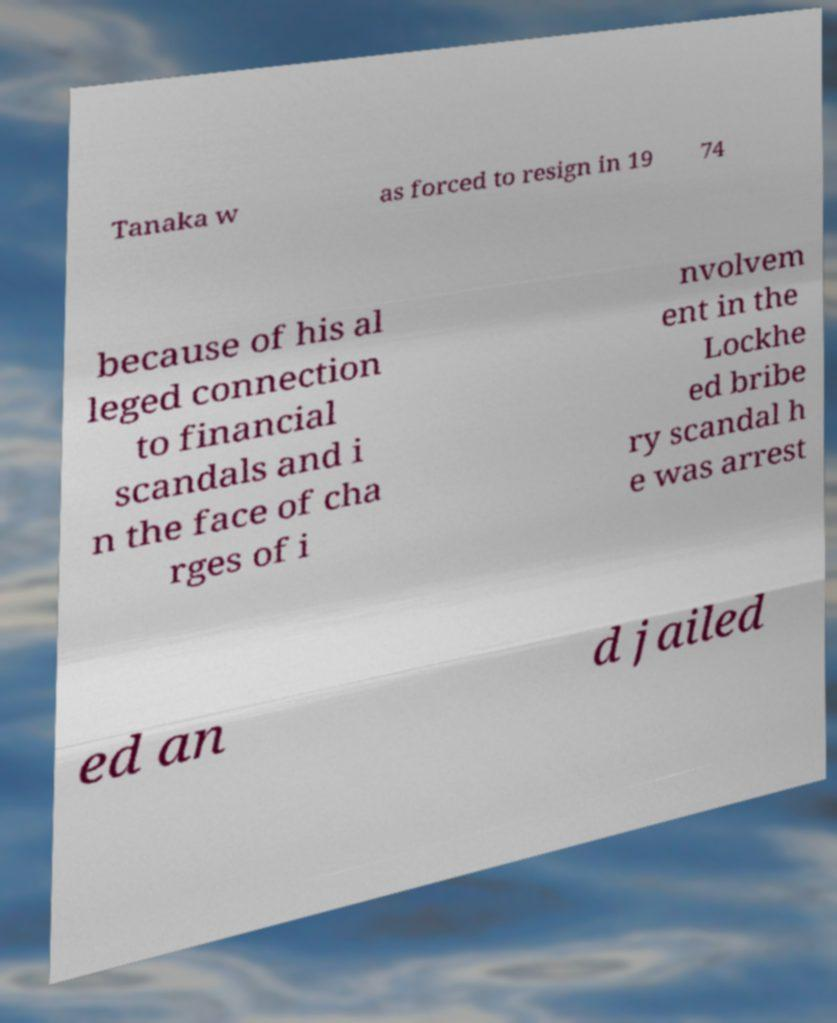What messages or text are displayed in this image? I need them in a readable, typed format. Tanaka w as forced to resign in 19 74 because of his al leged connection to financial scandals and i n the face of cha rges of i nvolvem ent in the Lockhe ed bribe ry scandal h e was arrest ed an d jailed 